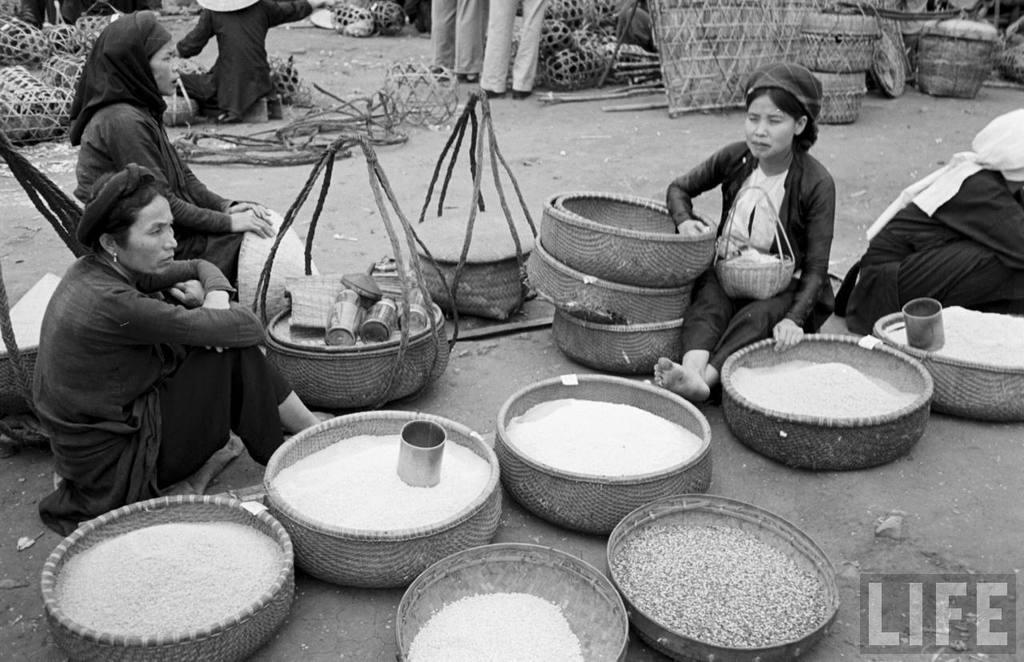In one or two sentences, can you explain what this image depicts? In this picture I can see there are few women sitting on the floor and they have some baskets with them. There are food grains in the basket. 